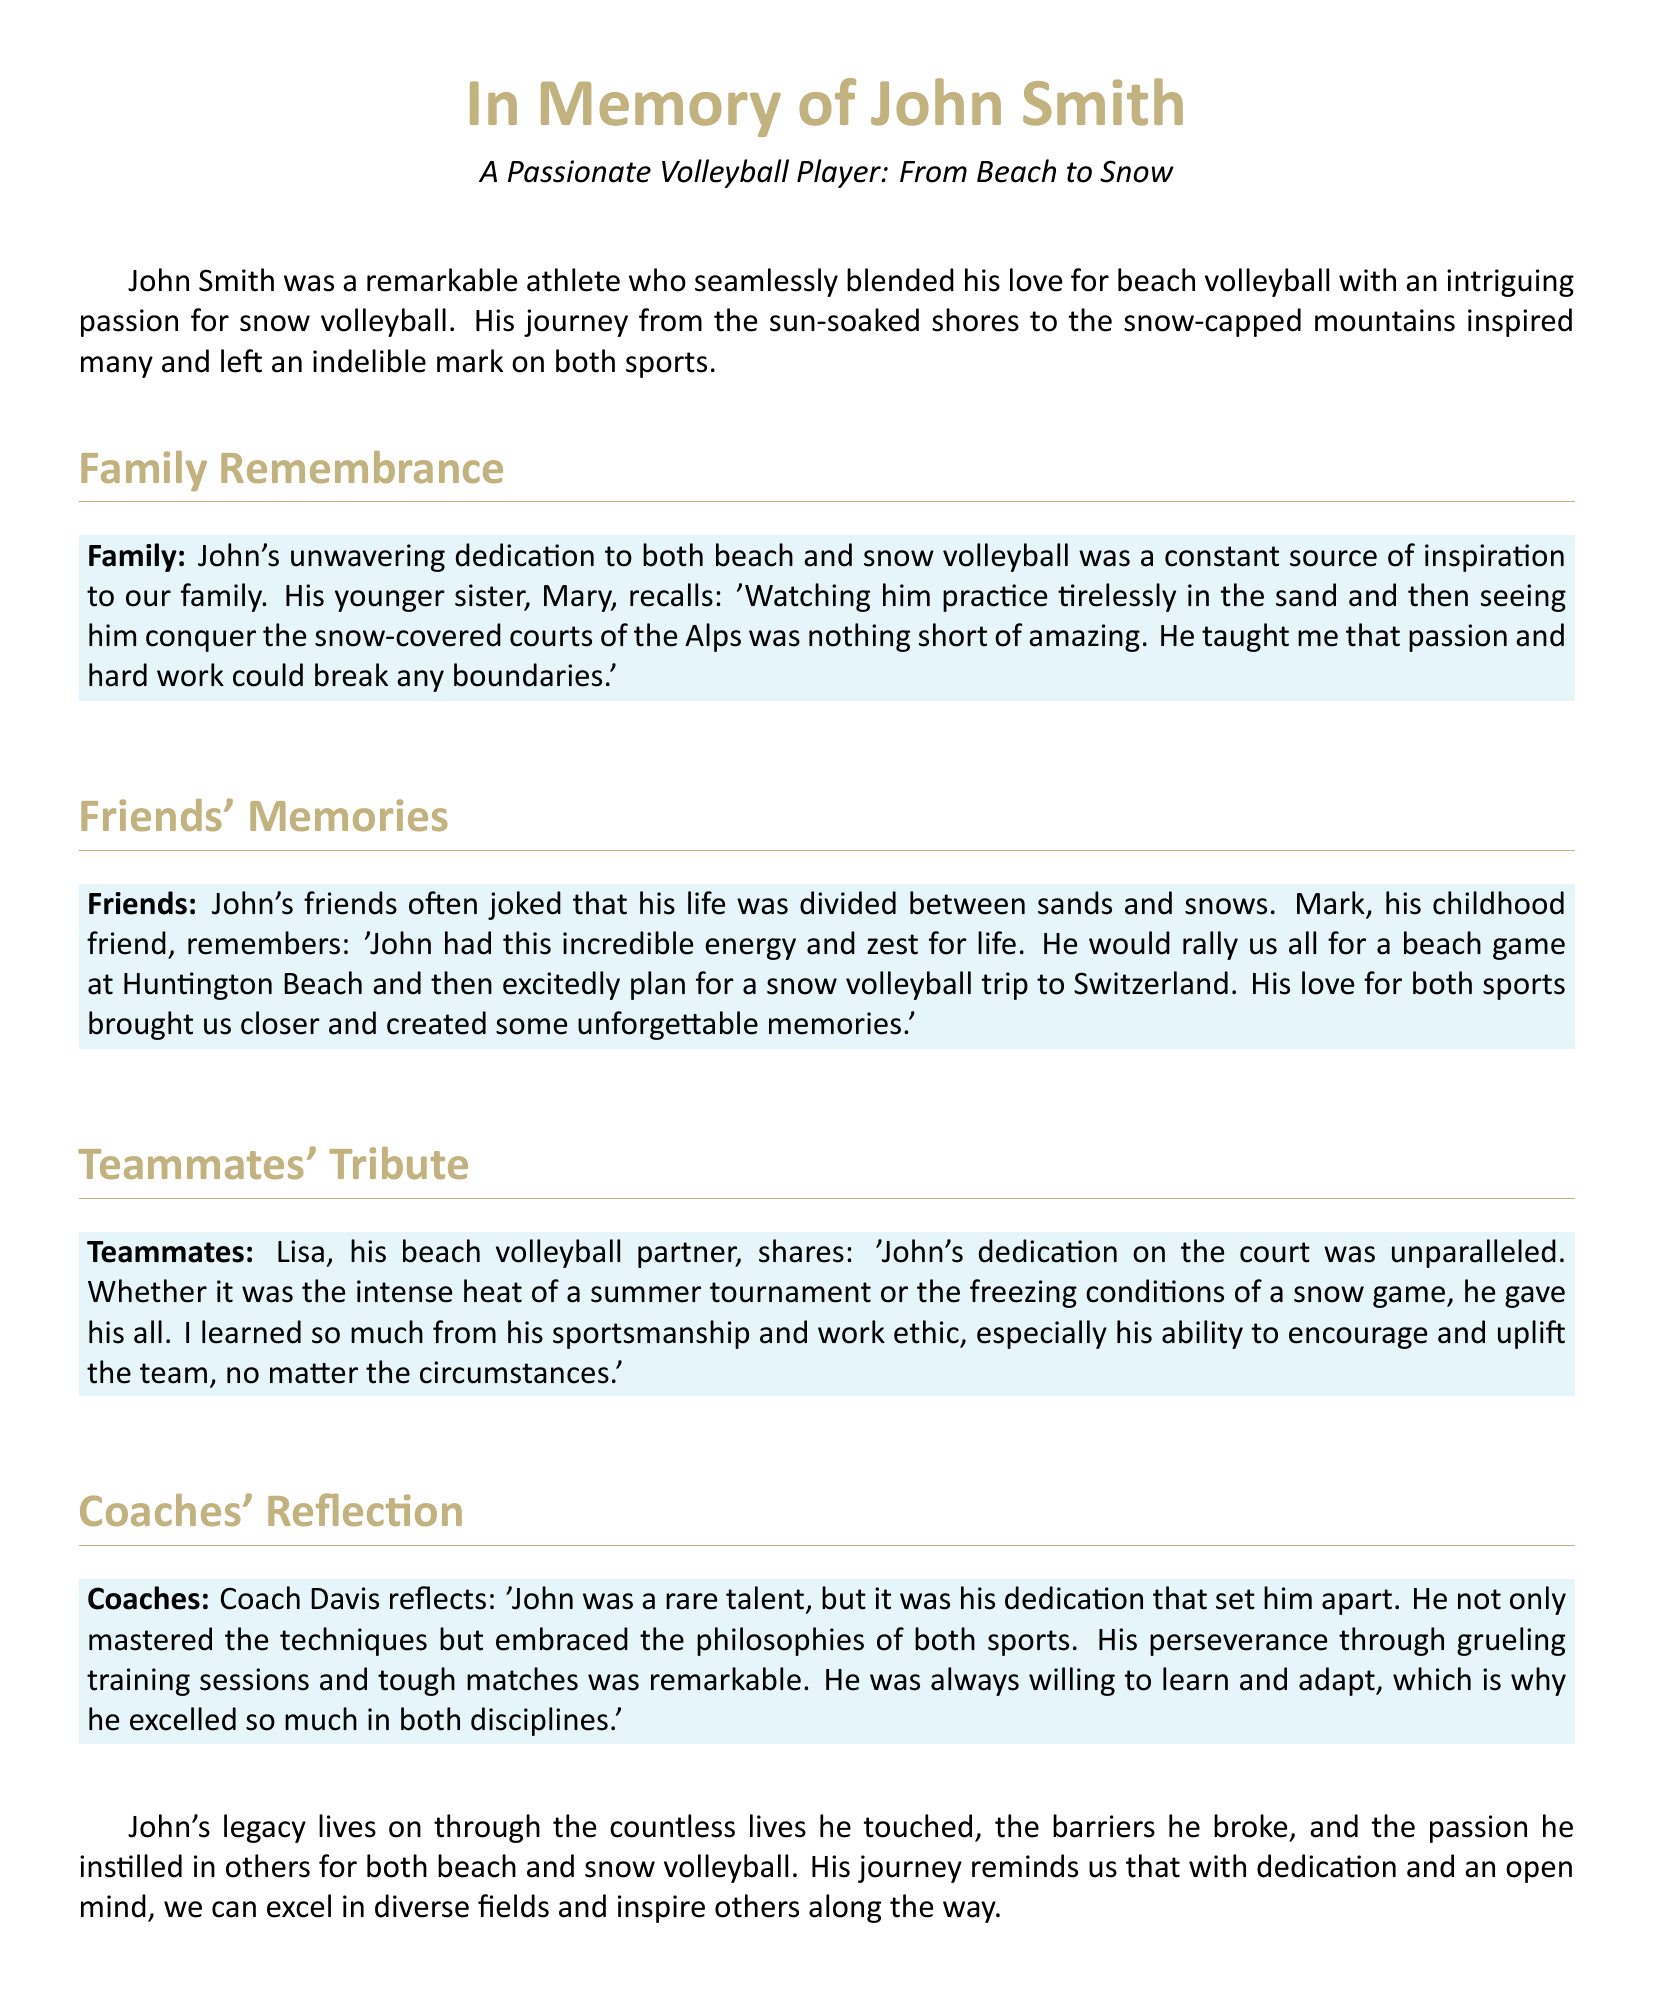What was John Smith's primary sport? The document highlights John Smith's primary involvement in beach volleyball, mentioning his passion and dedication to it.
Answer: beach volleyball Who describes watching John practice in the sand? The tribute section mentions John's younger sister, Mary, recounting her experiences of watching him practice.
Answer: Mary In which location did John plan snow volleyball trips? John's friends reminisced about their plans for snow volleyball trips to a specific location that is mentioned in the document.
Answer: Switzerland What was one quality that Coach Davis attributed to John? Coach Davis reflected on John's commitment and ability to learn, which is emphasized throughout his tribute.
Answer: dedication Which sports did John Smith engage in according to the document? The eulogy lists both beach volleyball and snow volleyball as sports John was passionate about.
Answer: beach and snow volleyball What did Lisa, his beach volleyball partner, learn from John? Lisa mentioned gaining insights from John's exemplary qualities that pertained to teamwork and support.
Answer: sportsmanship How did Mark describe John's energy? Mark characterized John’s energy in a way that reflects his vibrant personality during their activities together.
Answer: incredible What does John's legacy consist of? The document encapsulates John's impact through various aspects, including the lives he influenced and the passion he spread for the sports.
Answer: countless lives he touched 